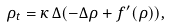Convert formula to latex. <formula><loc_0><loc_0><loc_500><loc_500>\rho _ { t } = \kappa \, \Delta ( - \Delta \rho + f ^ { \prime } ( \rho ) ) ,</formula> 